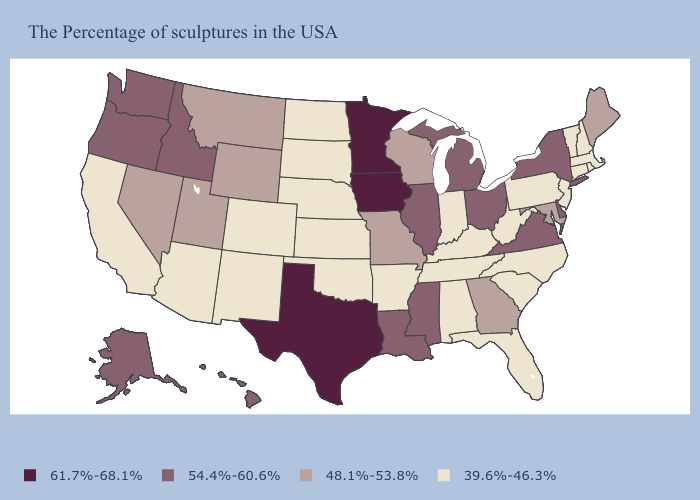What is the value of Alabama?
Keep it brief. 39.6%-46.3%. What is the lowest value in the Northeast?
Write a very short answer. 39.6%-46.3%. Does the map have missing data?
Keep it brief. No. How many symbols are there in the legend?
Write a very short answer. 4. Among the states that border Arkansas , which have the lowest value?
Answer briefly. Tennessee, Oklahoma. What is the lowest value in states that border Virginia?
Answer briefly. 39.6%-46.3%. Which states have the highest value in the USA?
Write a very short answer. Minnesota, Iowa, Texas. What is the value of Wyoming?
Quick response, please. 48.1%-53.8%. Name the states that have a value in the range 39.6%-46.3%?
Be succinct. Massachusetts, Rhode Island, New Hampshire, Vermont, Connecticut, New Jersey, Pennsylvania, North Carolina, South Carolina, West Virginia, Florida, Kentucky, Indiana, Alabama, Tennessee, Arkansas, Kansas, Nebraska, Oklahoma, South Dakota, North Dakota, Colorado, New Mexico, Arizona, California. What is the highest value in the USA?
Answer briefly. 61.7%-68.1%. What is the value of Texas?
Keep it brief. 61.7%-68.1%. Is the legend a continuous bar?
Keep it brief. No. What is the value of Nebraska?
Write a very short answer. 39.6%-46.3%. Among the states that border Nevada , which have the highest value?
Write a very short answer. Idaho, Oregon. Does Georgia have the highest value in the South?
Keep it brief. No. 